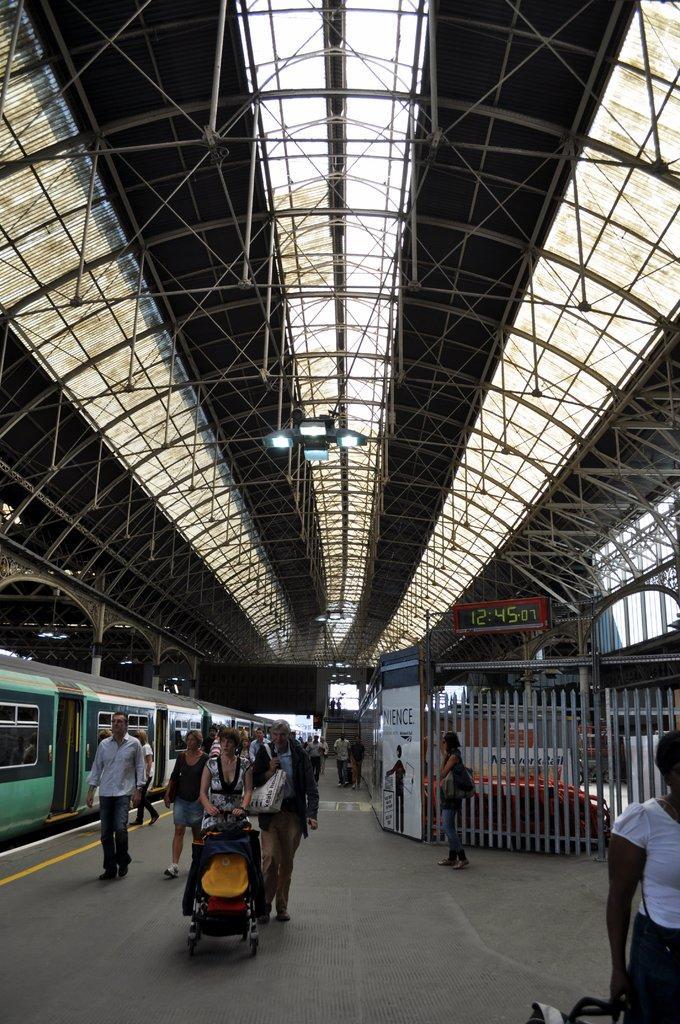Can you describe this image briefly? In this picture I can see in the middle few persons are walking, on the left side there is a train. At the top there are lights, on the right side there is a digital clock, it looks like a railway station. 